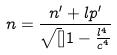<formula> <loc_0><loc_0><loc_500><loc_500>n = \frac { n ^ { \prime } + l p ^ { \prime } } { \sqrt { [ } ] { 1 - \frac { l ^ { 4 } } { c ^ { 4 } } } }</formula> 